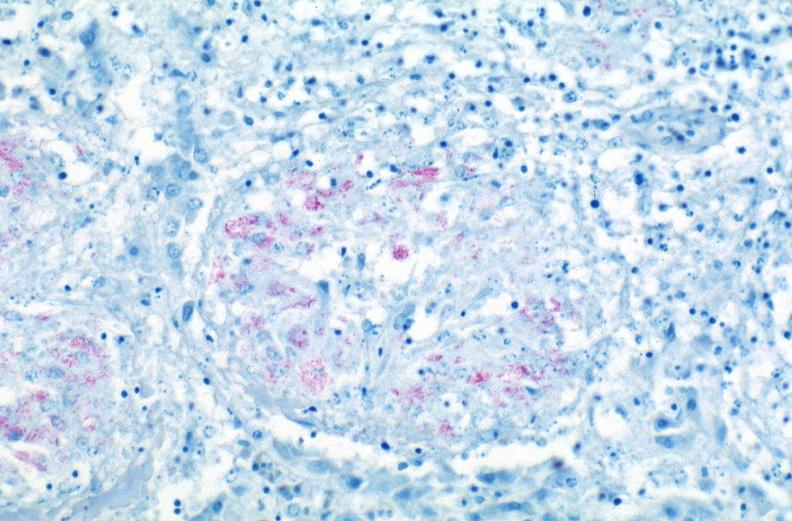does frontal slab of liver show lung, mycobacterium tuberculosis, acid fast?
Answer the question using a single word or phrase. No 